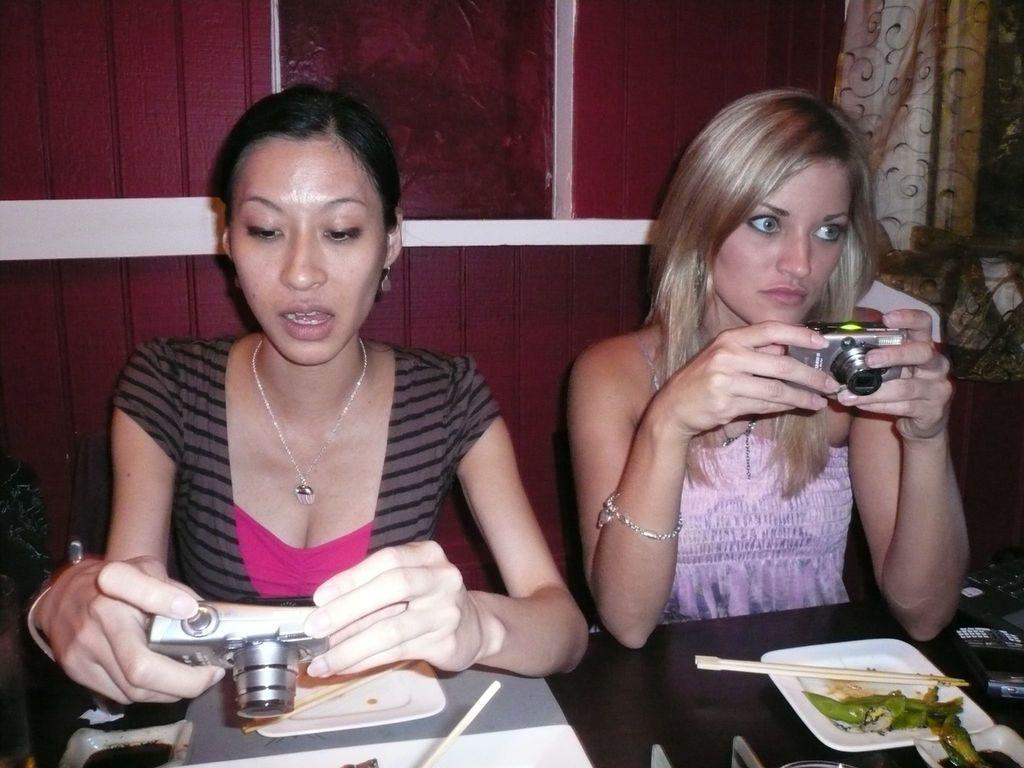How would you summarize this image in a sentence or two? In this image, There is a black color table on that there are some plates and there are two women sitting on the chairs and holding the cameras and in the background there is a wall of brown color. 